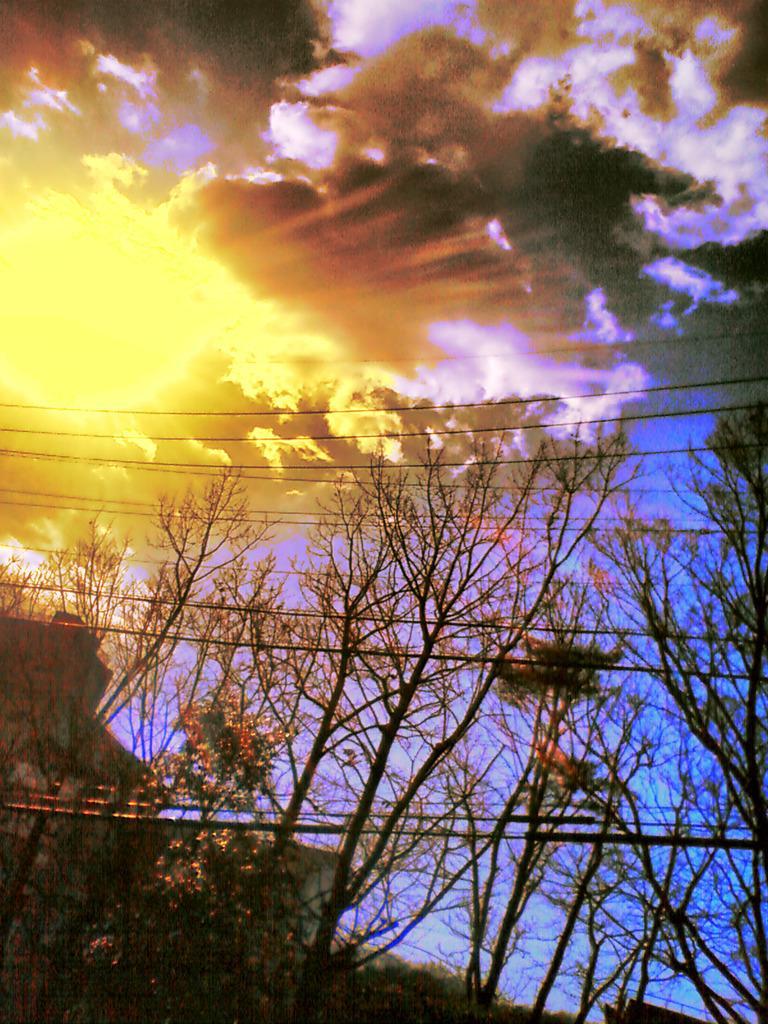In one or two sentences, can you explain what this image depicts? In this picture there are trees and there are wires and there is a building. At the top there is sky and there are clouds and there is sun. 